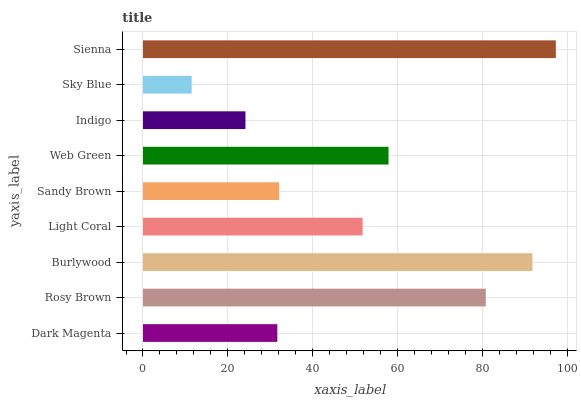Is Sky Blue the minimum?
Answer yes or no. Yes. Is Sienna the maximum?
Answer yes or no. Yes. Is Rosy Brown the minimum?
Answer yes or no. No. Is Rosy Brown the maximum?
Answer yes or no. No. Is Rosy Brown greater than Dark Magenta?
Answer yes or no. Yes. Is Dark Magenta less than Rosy Brown?
Answer yes or no. Yes. Is Dark Magenta greater than Rosy Brown?
Answer yes or no. No. Is Rosy Brown less than Dark Magenta?
Answer yes or no. No. Is Light Coral the high median?
Answer yes or no. Yes. Is Light Coral the low median?
Answer yes or no. Yes. Is Dark Magenta the high median?
Answer yes or no. No. Is Sky Blue the low median?
Answer yes or no. No. 